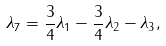Convert formula to latex. <formula><loc_0><loc_0><loc_500><loc_500>\lambda _ { 7 } = \frac { 3 } { 4 } \lambda _ { 1 } - \frac { 3 } { 4 } \lambda _ { 2 } - \lambda _ { 3 } ,</formula> 